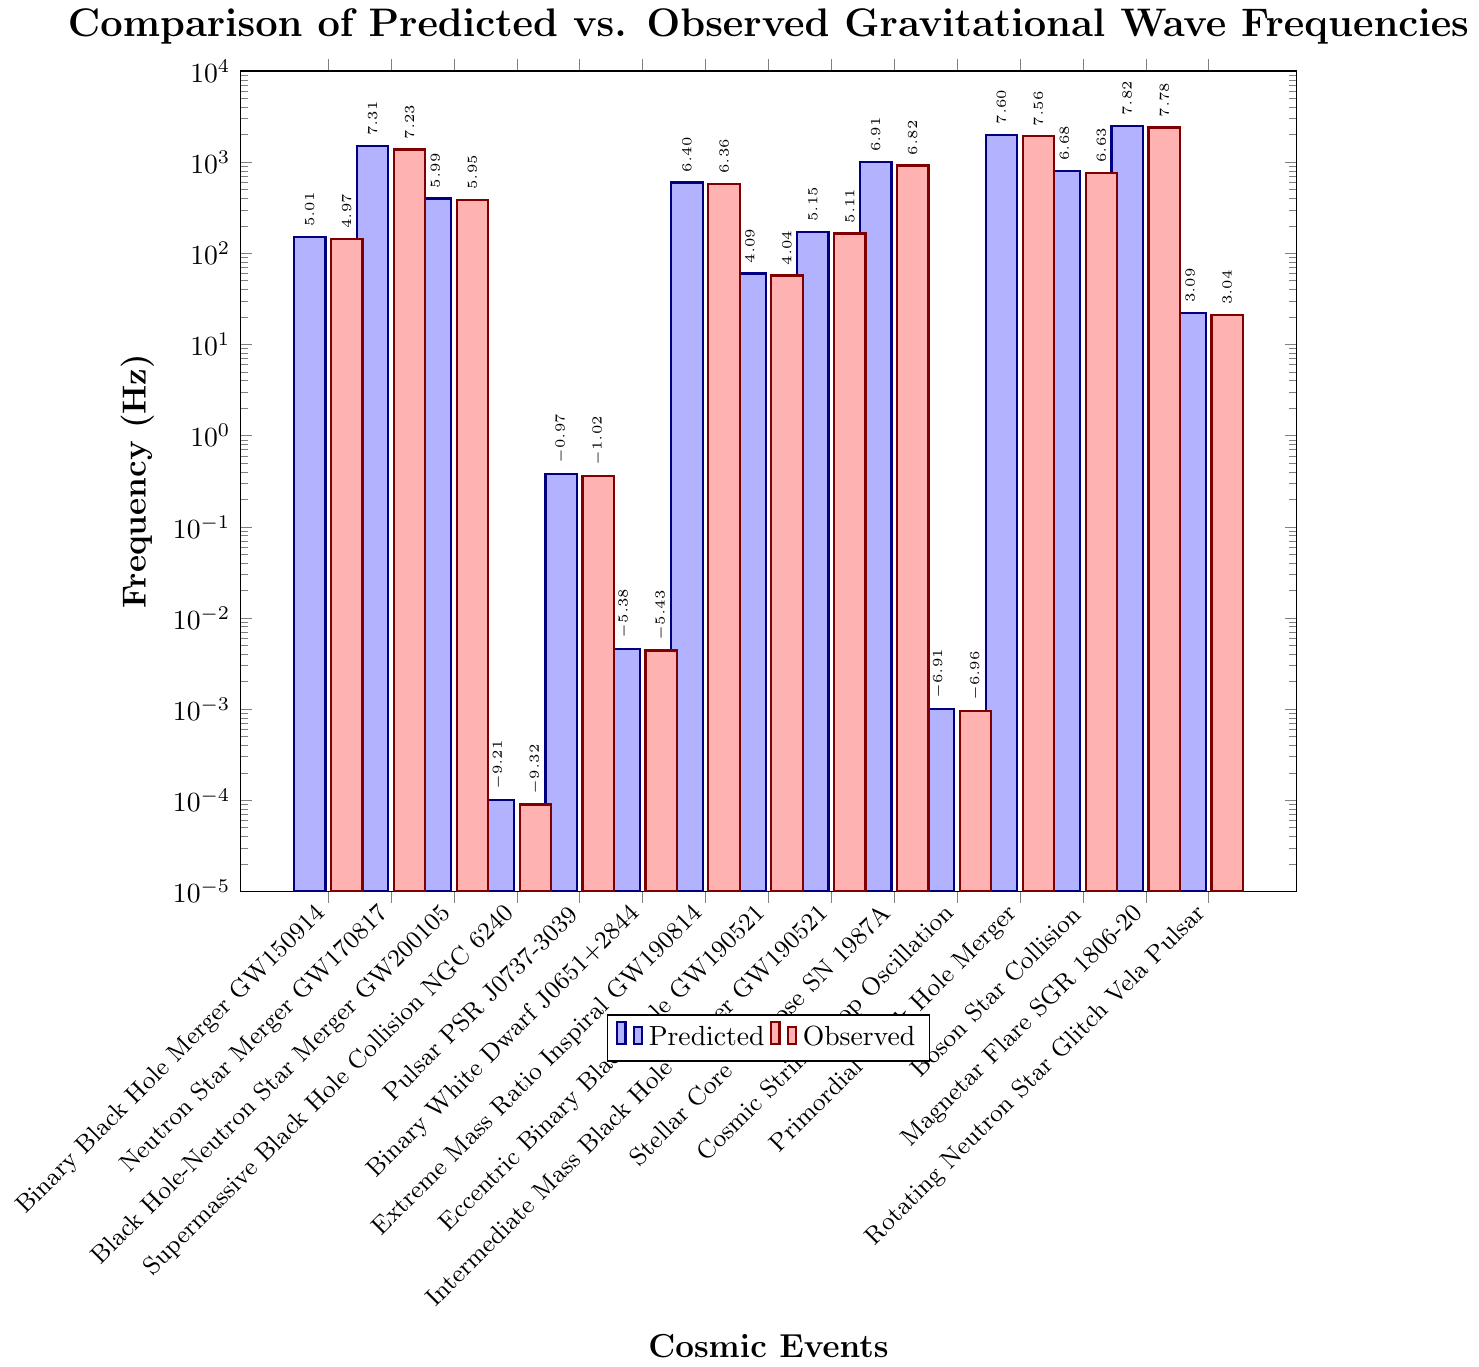Which cosmic event has the largest difference between predicted and observed frequencies? The largest difference can be found by subtracting the observed frequency from the predicted frequency for each event and comparing the results. The Primordial Black Hole Merger has the largest difference (2000 - 1920 = 80 Hz).
Answer: Primordial Black Hole Merger What is the average predicted frequency for the Neutron Star Merger GW170817 and Stellar Core Collapse SN 1987A? First, sum the predicted frequencies for Neutron Star Merger GW170817 (1500 Hz) and Stellar Core Collapse SN 1987A (1000 Hz). Then, divide by 2 to get the average. (1500 + 1000) / 2 = 1250 Hz.
Answer: 1250 Hz Which event has nearly equal predicted and observed frequencies closest to 0 Hz? Compare the predicted and observed frequencies for all events near 0 Hz. The Supermassive Black Hole Collision NGC 6240 has predicted and observed frequencies of 0.0001 Hz and 0.00009 Hz, respectively.
Answer: Supermassive Black Hole Collision NGC 6240 Among detected frequencies above 1000 Hz, which event has the smallest difference between predicted and observed frequencies? First, identify events with predicted frequencies above 1000 Hz: Neutron Star Merger GW170817, Stellar Core Collapse SN 1987A, and Magnetar Flare SGR 1806-20. Calculate the differences: 1500-1375=125, 1000-920=80, and 2500-2400=100. The smallest difference is 80 for Stellar Core Collapse SN 1987A.
Answer: Stellar Core Collapse SN 1987A Which event has the smallest observed frequency? By visually inspecting the heights of the red bars representing observed frequencies, the event with the smallest frequency is the Supermassive Black Hole Collision NGC 6240 with 0.00009 Hz.
Answer: Supermassive Black Hole Collision NGC 6240 